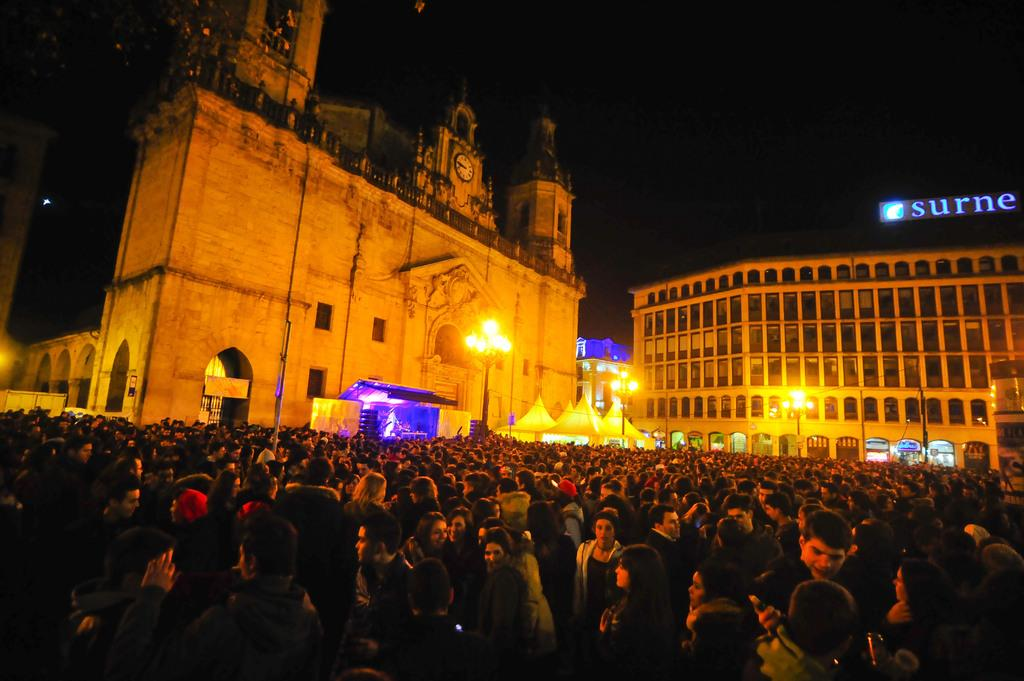What is the main subject of the image? The main subject of the image is a crowd. What can be seen in the background of the image? The background of the image includes a dark sky, buildings, light poles, a hoarding, and tents. Can you describe any specific objects in the image? Yes, there is a clock in the image. What type of art can be seen on the faces of the people in the crowd? There is no mention of faces or art on the faces of the people in the image. The image focuses on the crowd as a whole and does not provide details about individual faces. 